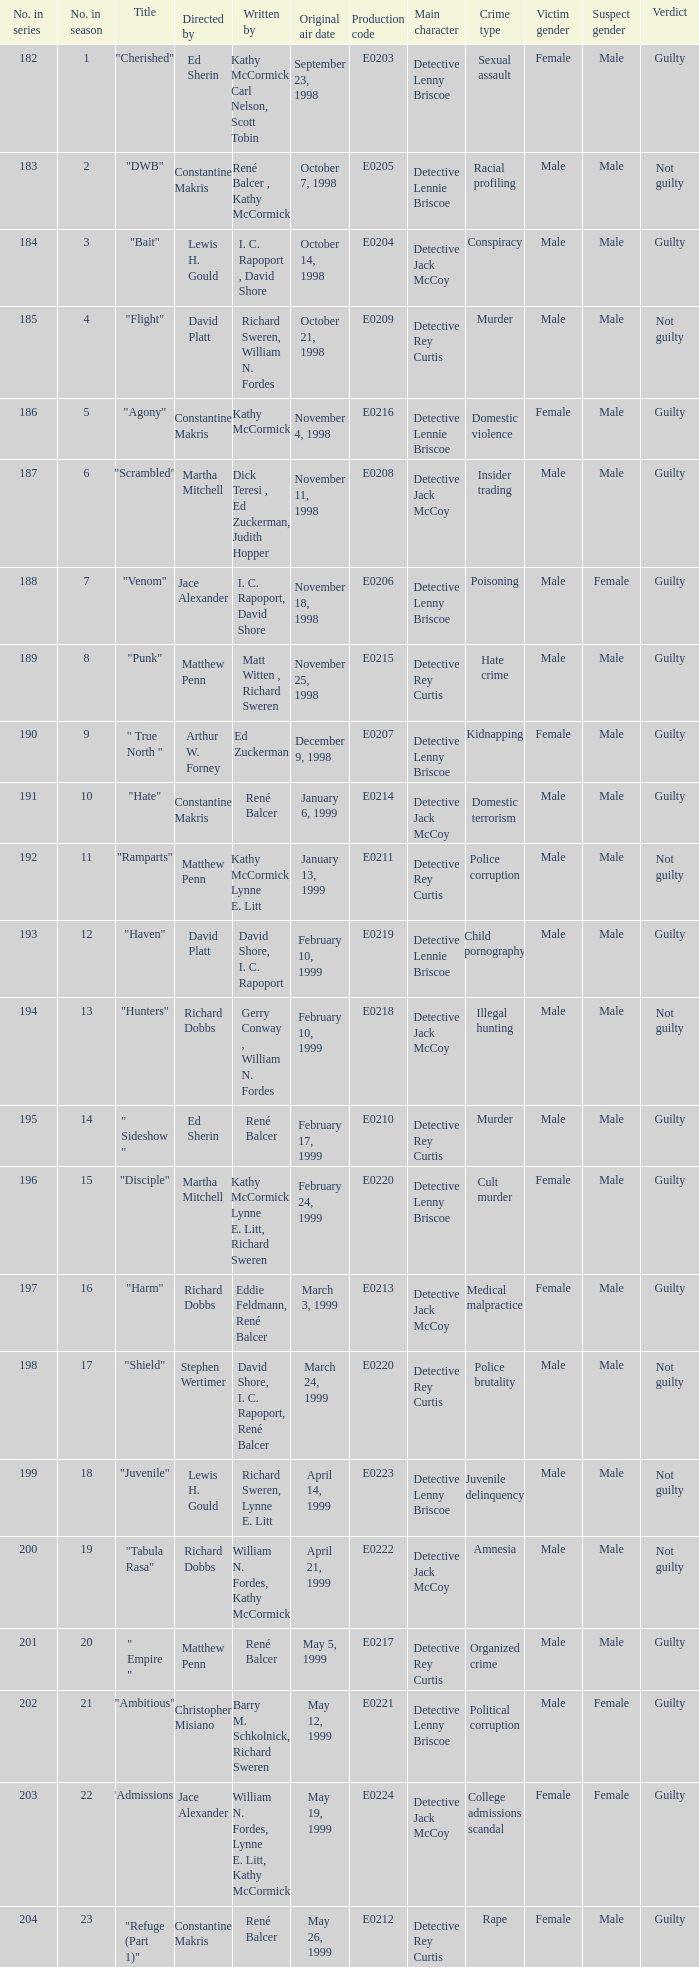What is the title of the episode with the original air date October 21, 1998? "Flight". 